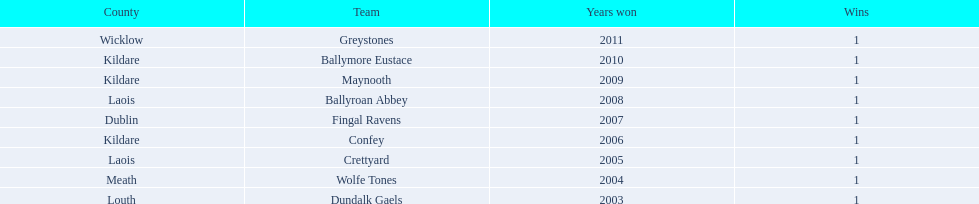What is the number of wins for each team 1. 